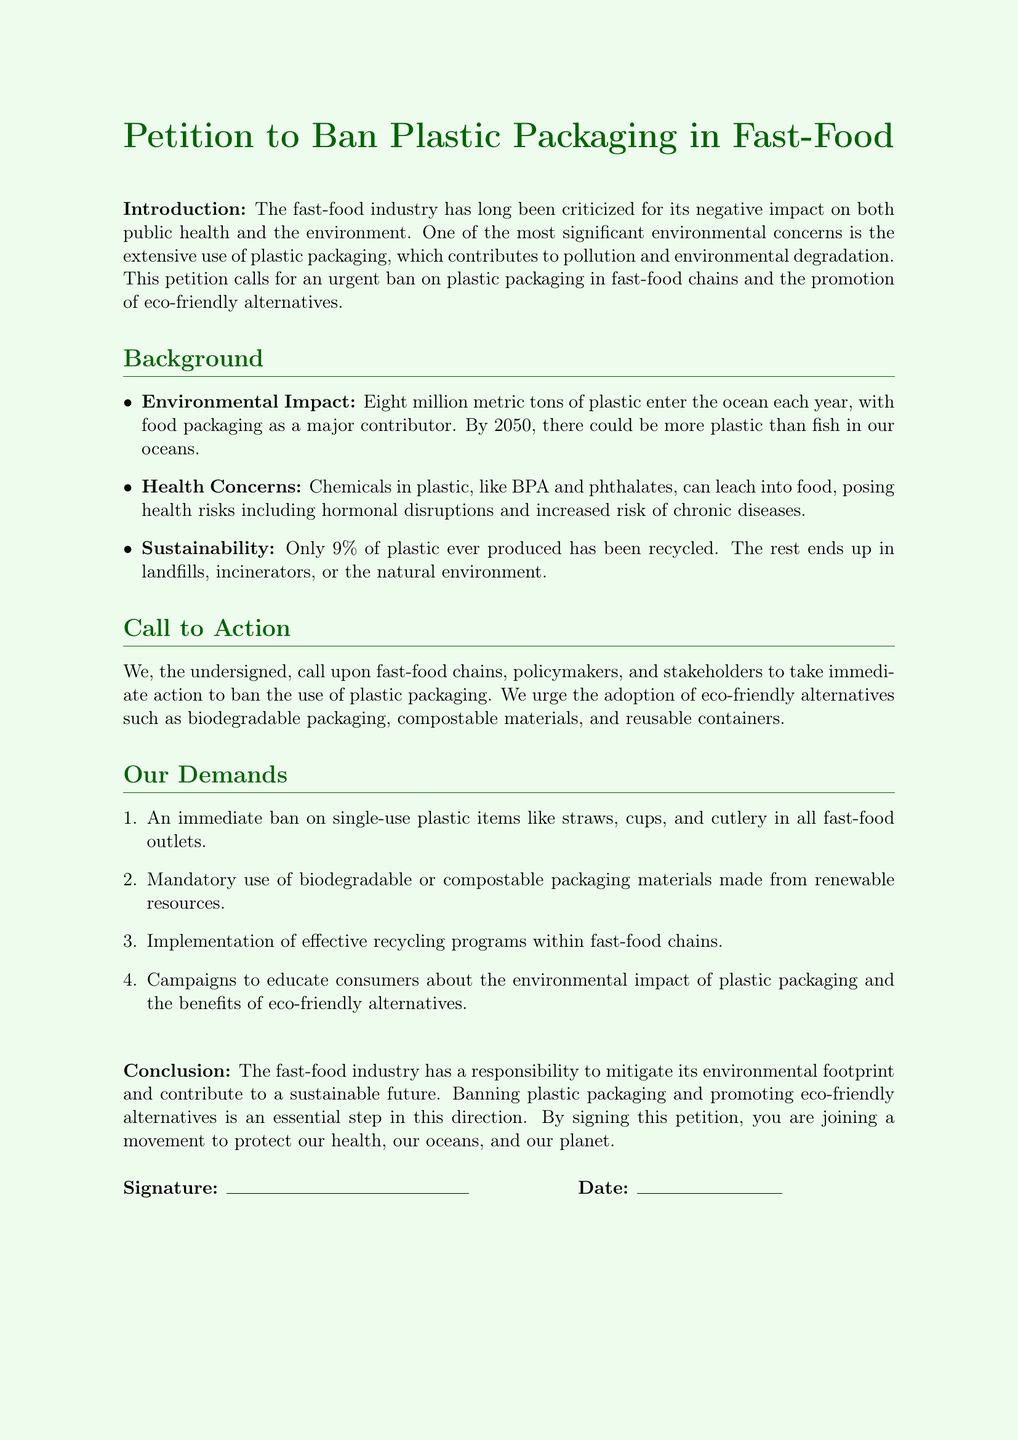What is the primary focus of the petition? The petition calls for an urgent ban on plastic packaging in fast-food chains and the promotion of eco-friendly alternatives.
Answer: Ban plastic packaging How much plastic enters the ocean each year? The document states that eight million metric tons of plastic enter the ocean each year.
Answer: Eight million metric tons What health risk is associated with chemicals in plastic? Chemicals like BPA and phthalates can leach into food, posing health risks including hormonal disruptions.
Answer: Hormonal disruptions What percentage of plastic ever produced has been recycled? The document mentions that only 9% of plastic ever produced has been recycled.
Answer: 9% What is one of the documented demands of the petition? The petition demands an immediate ban on single-use plastic items like straws, cups, and cutlery.
Answer: Ban single-use plastic items What can fast-food chains implement according to the petition? The petition states that fast-food chains should implement effective recycling programs.
Answer: Effective recycling programs What type of materials should be mandatory according to the demands? The demands include the use of biodegradable or compostable packaging materials made from renewable resources.
Answer: Biodegradable or compostable materials What is the document type? The document is a petition addressed to fast-food chains, policymakers, and stakeholders.
Answer: Petition How does the document describe the fast-food industry's responsibility? The conclusion states that the fast-food industry has a responsibility to mitigate its environmental footprint and contribute to a sustainable future.
Answer: Mitigate environmental footprint 